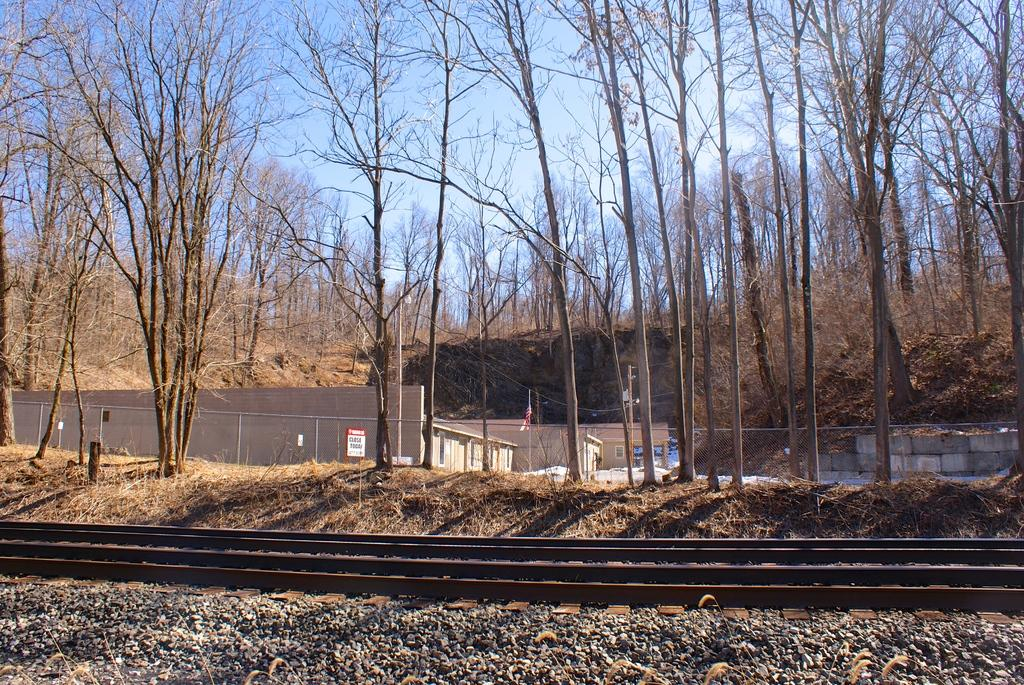What type of objects can be seen on the ground in the image? There are stones in the image. What type of transportation infrastructure is present in the image? Railway tracks are present in the image. What type of barrier can be seen in the image? There is a fence in the image. What type of structures are visible in the image? There are buildings in the image. What type of vegetation is visible in the image? Trees are visible in the image. What is visible in the background of the image? The sky is visible in the background of the image. How many tents are set up in the image? There are no tents present in the image. What country is depicted in the image? The image does not depict a specific country; it shows a scene with stones, railway tracks, a fence, buildings, trees, and the sky. 